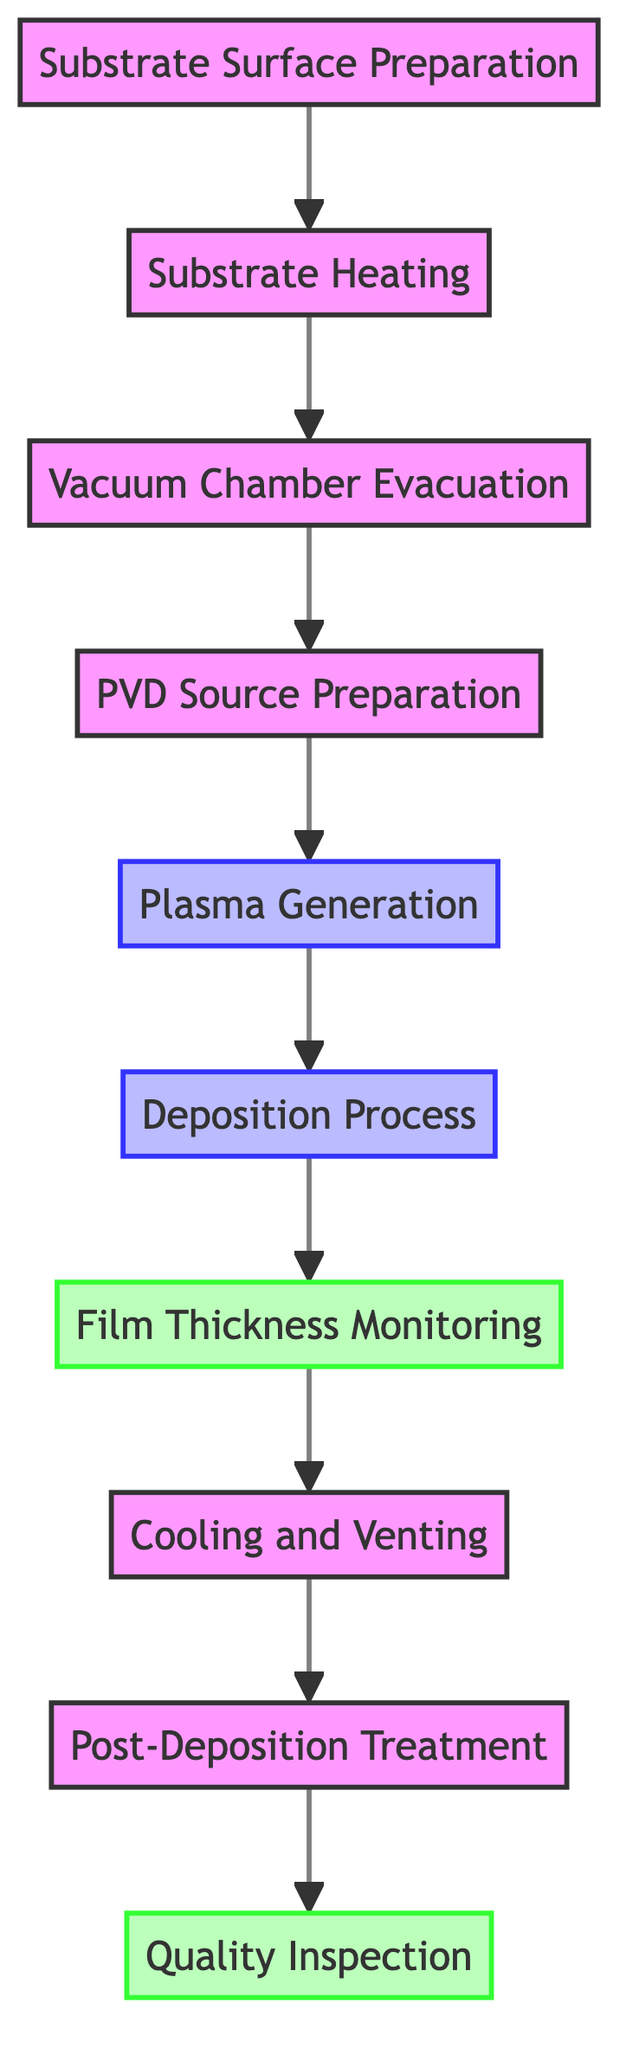What is the first step in the PVD coating process? The diagram indicates that the first step is "Substrate Surface Preparation." This is the starting node from which the flow continues.
Answer: Substrate Surface Preparation How many steps are involved in the deposition process? By counting the nodes in the diagram, there are a total of ten steps listed from substrate preparation to quality inspection.
Answer: 10 What follows the "Plasma Generation" step? The flowchart shows that "Plasma Generation" directly leads to the "Deposition Process," indicating that after plasma is generated, the deposition occurs.
Answer: Deposition Process What type of monitoring is included in the PVD process? The diagram specifies "Film Thickness Monitoring" as a unique monitoring step that occurs after the deposition process.
Answer: Film Thickness Monitoring Which step occurs after "Cooling and Venting"? The diagram illustrates that "Post-Deposition Treatment" is the step that follows "Cooling and Venting" in the sequential flow of the PVD process.
Answer: Post-Deposition Treatment How does the "Vacuum Chamber Evacuation" relate to substrate preparation? The diagram indicates that "Vacuum Chamber Evacuation" follows "Substrate Heating," which means that after cleaning, the substrate must be heated before the vacuum is established.
Answer: It is the third step after heating What is the final process in this flowchart? The last node of the flowchart is "Quality Inspection," which concludes the series of steps involved in the PVD process.
Answer: Quality Inspection What is the main purpose of substrate heating? According to the details provided, the purpose of substrate heating is to enhance adhesion and film quality during the deposition process, which is emphasized at that step.
Answer: Enhance adhesion and film quality What is necessary to ensure a clean deposition environment? The diagram indicates "Evacuate the vacuum chamber to a base pressure of 10^-6 to 10^-9 Torr" as the means to minimize contamination and ensure cleanliness.
Answer: Evacuate to a base pressure of 10^-6 to 10^-9 Torr Which step emphasizes the control of film properties? The "Deposition Process" step is highlighted for maintaining parameters like power, pressure, and substrate bias to control the properties of the film being deposited.
Answer: Deposition Process 